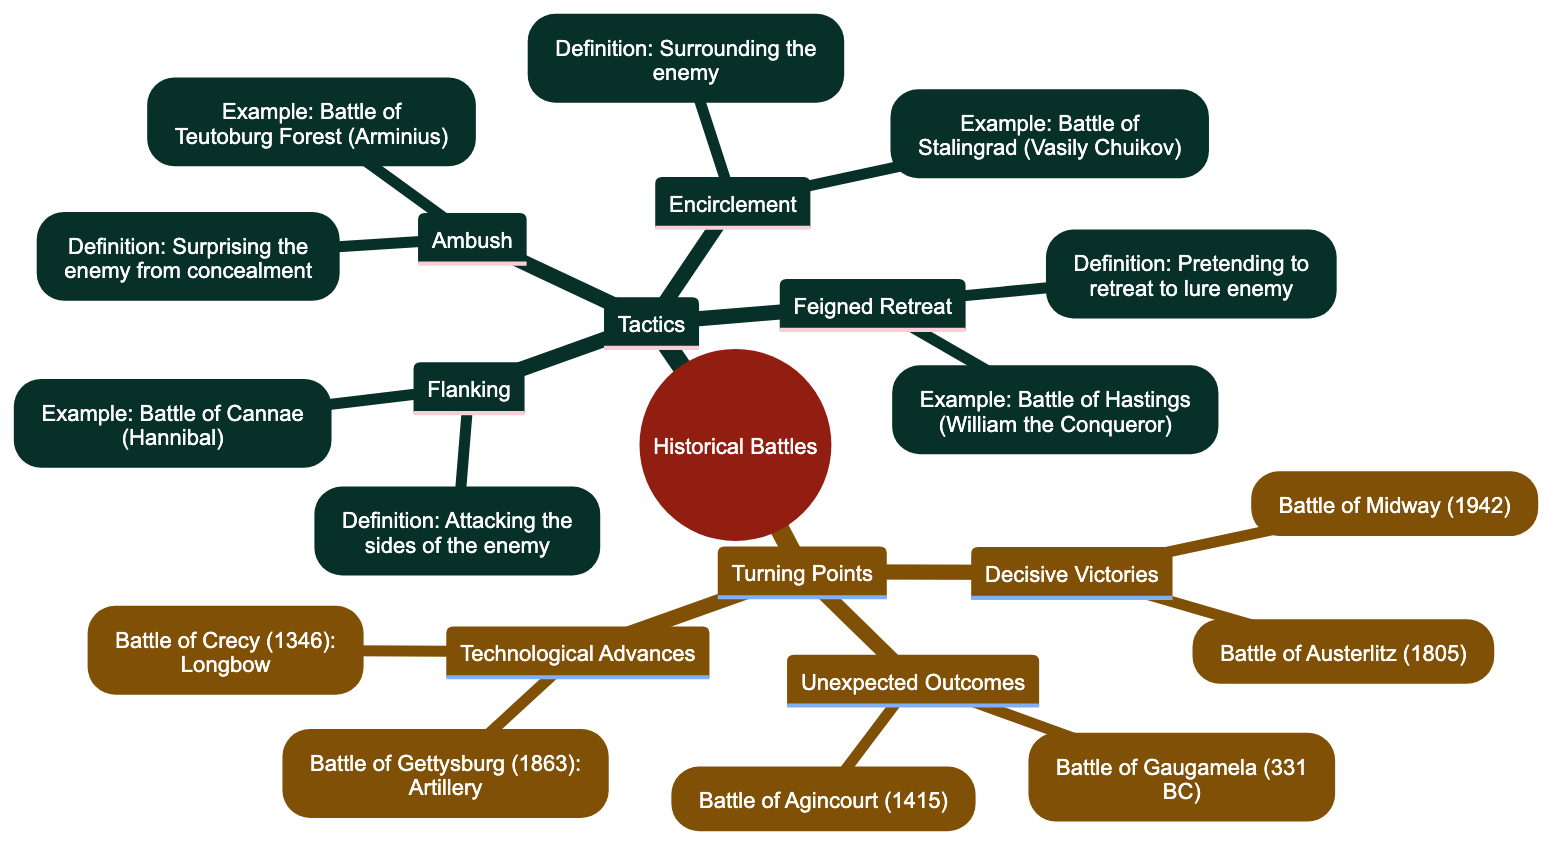What is the definition of flanking in military tactics? The diagram states that flanking involves "Attacking the sides of the enemy to gain a strategic advantage." By referring to the "Flanking" section under "Tactics," we find the provided definition.
Answer: Attacking the sides of the enemy to gain a strategic advantage Which battle is associated with the commander Arminius? In the "Ambush" section, it states the battle associated with Arminius is the "Battle of the Teutoburg Forest." Therefore, by locating the commander's name, we can deduce the related battle.
Answer: Battle of the Teutoburg Forest What year was the Battle of Gettysburg? The "Technological Advances" subsection lists the Battle of Gettysburg with the year "1863." By identifying the Battle of Gettysburg in that section, we can directly answer the question regarding the year of occurrence.
Answer: 1863 How many tactics are listed in the mind map? The "Tactics" section contains four specific strategies: Flanking, Ambush, Encirclement, and Feigned Retreat. By counting each listed tactic in that section, we arrive at the total number.
Answer: 4 What significant event is associated with the Battle of Austerlitz? The diagram explains that the Battle of Austerlitz, occurring in 1805, is marked as the pinnacle of Napoleon's military career. By referencing the Decisive Victories section, we combine the battle's name, year, and significance.
Answer: Marked the pinnacle of Napoleon's military career Which tactic involves pretending to retreat? According to the "Tactics" section, the tactic that involves pretending to retreat is called "Feigned Retreat." By examining the subsection completely, the specific name of that tactic can be identified.
Answer: Feigned Retreat What was the technological advance seen in the Battle of Crecy? The diagram specifies that the Battle of Crecy showcased "the effectiveness of the longbow." By looking at the relevant entry in the Technological Advances section, we can derive the answer related to this battle.
Answer: The effectiveness of the longbow Which battle represents a decisive victory in favor of the Allies during WWII? The "Decisive Victories" subsection notes the "Battle of Midway" as the event that turned the tide in favor of the Allies in the Pacific Theater during WWII. After identifying the battle, we answer based on that information.
Answer: Battle of Midway 